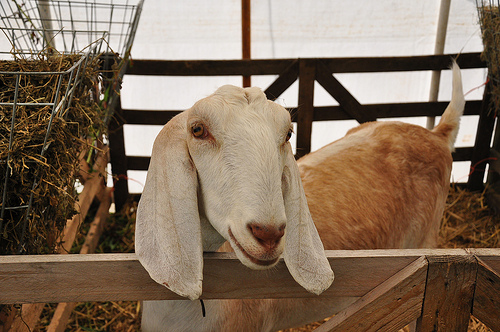<image>
Can you confirm if the goat is in the hay? Yes. The goat is contained within or inside the hay, showing a containment relationship. Is the goat in front of the gate? No. The goat is not in front of the gate. The spatial positioning shows a different relationship between these objects. 